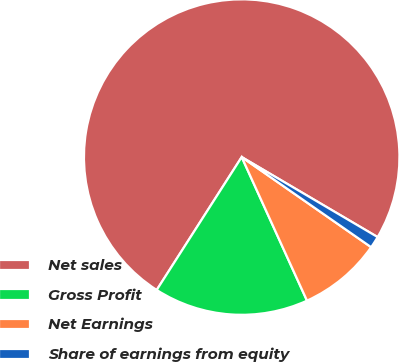Convert chart to OTSL. <chart><loc_0><loc_0><loc_500><loc_500><pie_chart><fcel>Net sales<fcel>Gross Profit<fcel>Net Earnings<fcel>Share of earnings from equity<nl><fcel>74.42%<fcel>15.85%<fcel>8.53%<fcel>1.21%<nl></chart> 